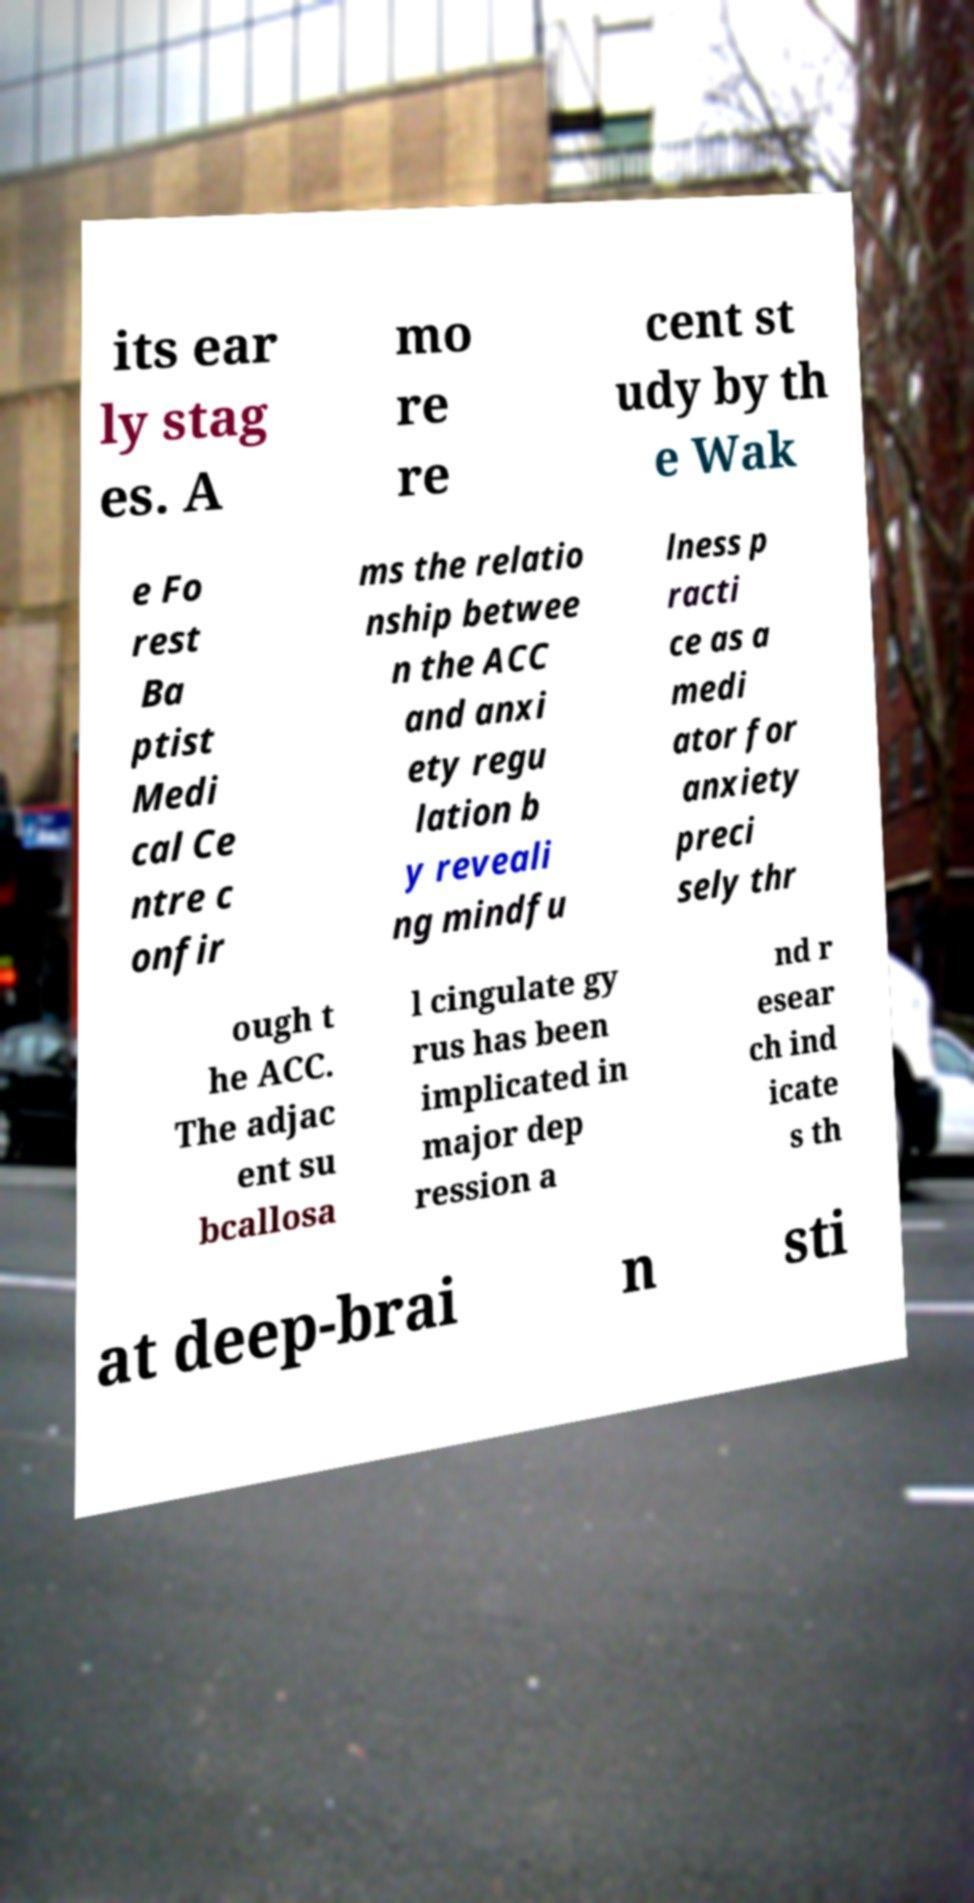What messages or text are displayed in this image? I need them in a readable, typed format. its ear ly stag es. A mo re re cent st udy by th e Wak e Fo rest Ba ptist Medi cal Ce ntre c onfir ms the relatio nship betwee n the ACC and anxi ety regu lation b y reveali ng mindfu lness p racti ce as a medi ator for anxiety preci sely thr ough t he ACC. The adjac ent su bcallosa l cingulate gy rus has been implicated in major dep ression a nd r esear ch ind icate s th at deep-brai n sti 